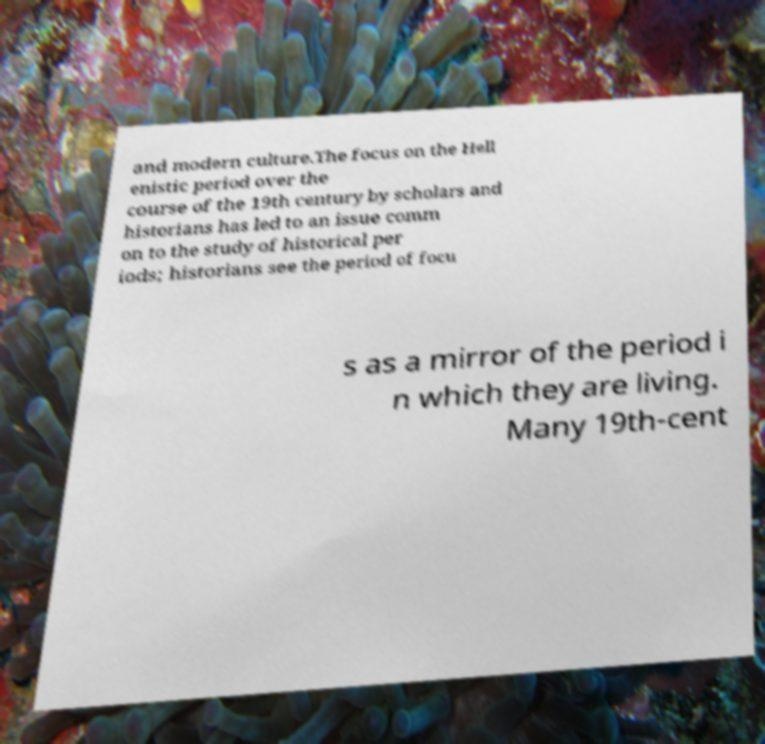For documentation purposes, I need the text within this image transcribed. Could you provide that? and modern culture.The focus on the Hell enistic period over the course of the 19th century by scholars and historians has led to an issue comm on to the study of historical per iods; historians see the period of focu s as a mirror of the period i n which they are living. Many 19th-cent 